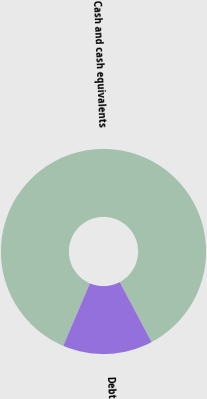Convert chart to OTSL. <chart><loc_0><loc_0><loc_500><loc_500><pie_chart><fcel>Cash and cash equivalents<fcel>Debt<nl><fcel>85.82%<fcel>14.18%<nl></chart> 